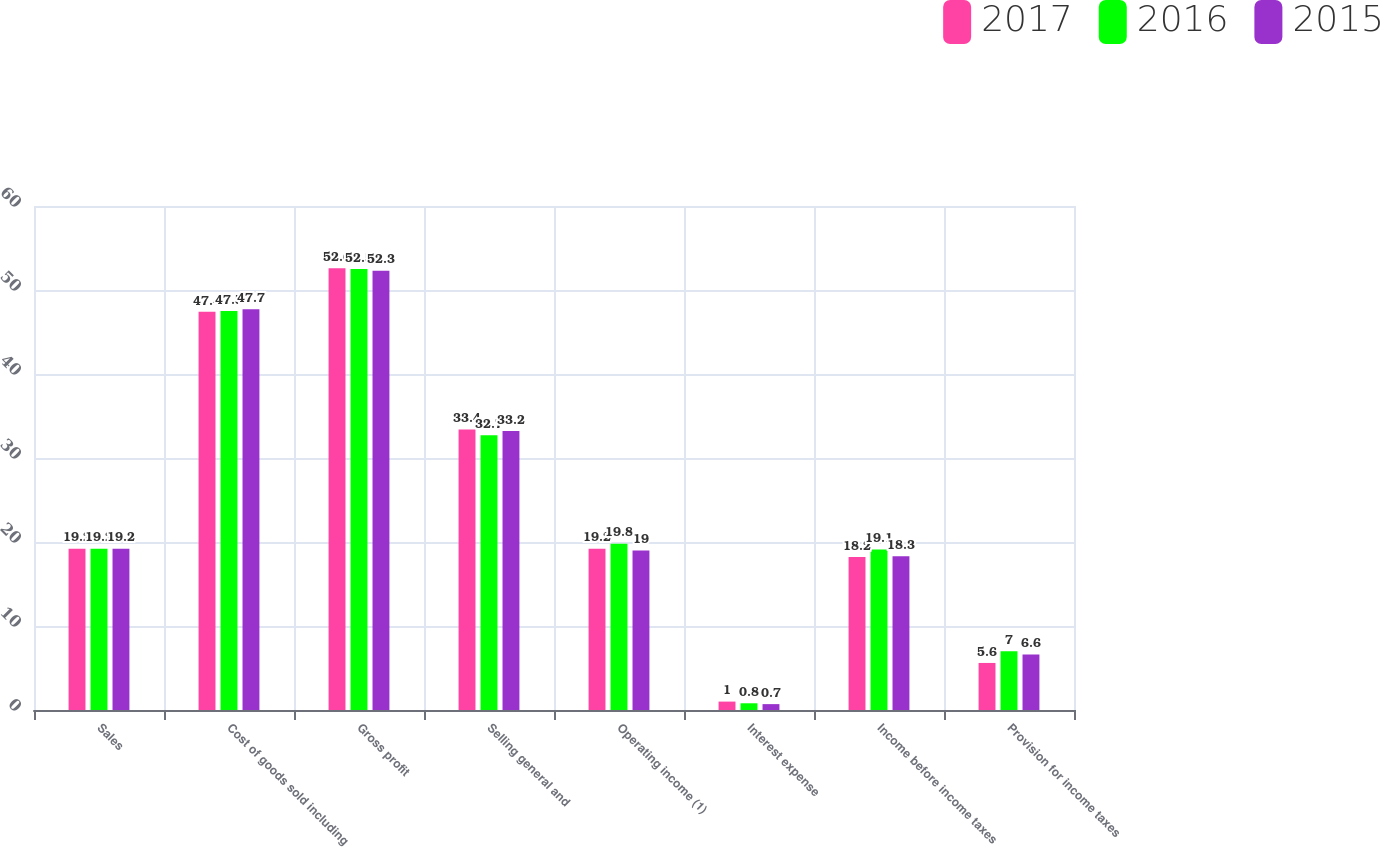<chart> <loc_0><loc_0><loc_500><loc_500><stacked_bar_chart><ecel><fcel>Sales<fcel>Cost of goods sold including<fcel>Gross profit<fcel>Selling general and<fcel>Operating income (1)<fcel>Interest expense<fcel>Income before income taxes<fcel>Provision for income taxes<nl><fcel>2017<fcel>19.2<fcel>47.4<fcel>52.6<fcel>33.4<fcel>19.2<fcel>1<fcel>18.2<fcel>5.6<nl><fcel>2016<fcel>19.2<fcel>47.5<fcel>52.5<fcel>32.7<fcel>19.8<fcel>0.8<fcel>19.1<fcel>7<nl><fcel>2015<fcel>19.2<fcel>47.7<fcel>52.3<fcel>33.2<fcel>19<fcel>0.7<fcel>18.3<fcel>6.6<nl></chart> 